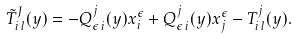<formula> <loc_0><loc_0><loc_500><loc_500>\tilde { T } ^ { J } _ { i \, l } ( y ) = - Q ^ { j } _ { \epsilon \, i } ( y ) x ^ { \epsilon } _ { i } + Q ^ { j } _ { \epsilon \, i } ( y ) x ^ { \epsilon } _ { j } - T ^ { j } _ { i \, l } ( y ) .</formula> 